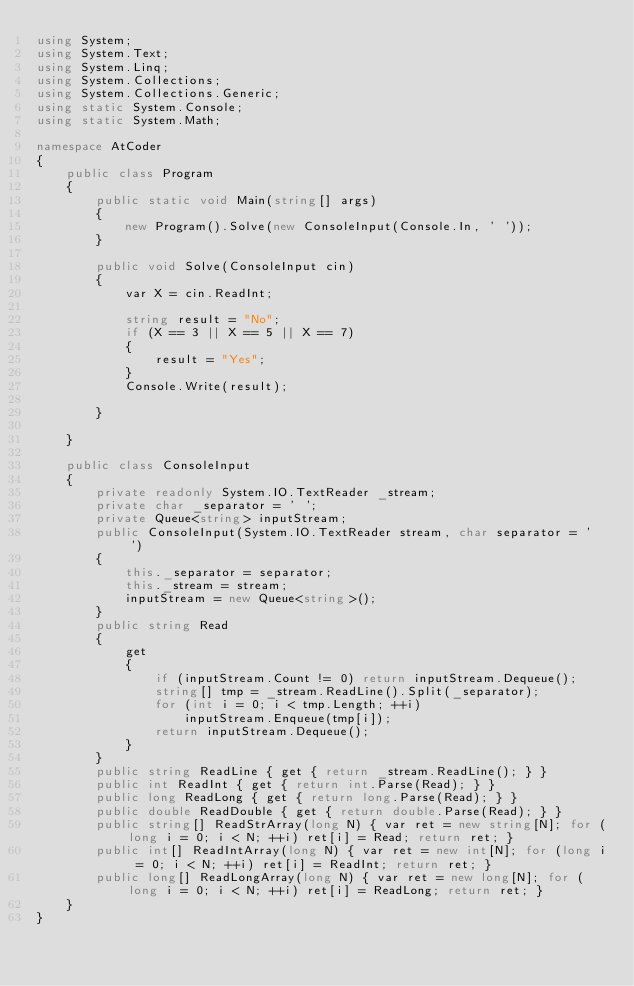Convert code to text. <code><loc_0><loc_0><loc_500><loc_500><_C#_>using System;
using System.Text;
using System.Linq;
using System.Collections;
using System.Collections.Generic;
using static System.Console;
using static System.Math;

namespace AtCoder
{
    public class Program
    {
        public static void Main(string[] args)
        {
            new Program().Solve(new ConsoleInput(Console.In, ' '));
        }

        public void Solve(ConsoleInput cin)
        {
            var X = cin.ReadInt;

            string result = "No";
            if (X == 3 || X == 5 || X == 7)
            {
                result = "Yes";
            }
            Console.Write(result);

        }

    }

    public class ConsoleInput
    {
        private readonly System.IO.TextReader _stream;
        private char _separator = ' ';
        private Queue<string> inputStream;
        public ConsoleInput(System.IO.TextReader stream, char separator = ' ')
        {
            this._separator = separator;
            this._stream = stream;
            inputStream = new Queue<string>();
        }
        public string Read
        {
            get
            {
                if (inputStream.Count != 0) return inputStream.Dequeue();
                string[] tmp = _stream.ReadLine().Split(_separator);
                for (int i = 0; i < tmp.Length; ++i)
                    inputStream.Enqueue(tmp[i]);
                return inputStream.Dequeue();
            }
        }
        public string ReadLine { get { return _stream.ReadLine(); } }
        public int ReadInt { get { return int.Parse(Read); } }
        public long ReadLong { get { return long.Parse(Read); } }
        public double ReadDouble { get { return double.Parse(Read); } }
        public string[] ReadStrArray(long N) { var ret = new string[N]; for (long i = 0; i < N; ++i) ret[i] = Read; return ret; }
        public int[] ReadIntArray(long N) { var ret = new int[N]; for (long i = 0; i < N; ++i) ret[i] = ReadInt; return ret; }
        public long[] ReadLongArray(long N) { var ret = new long[N]; for (long i = 0; i < N; ++i) ret[i] = ReadLong; return ret; }
    }
}</code> 